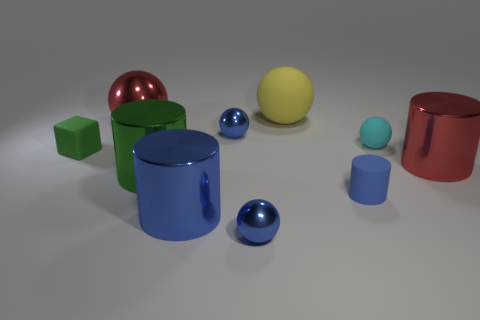There is a tiny metallic object that is in front of the big green shiny object; what color is it? The small metallic object situated in front of the larger green one appears to be a light blue or cyan in color. 